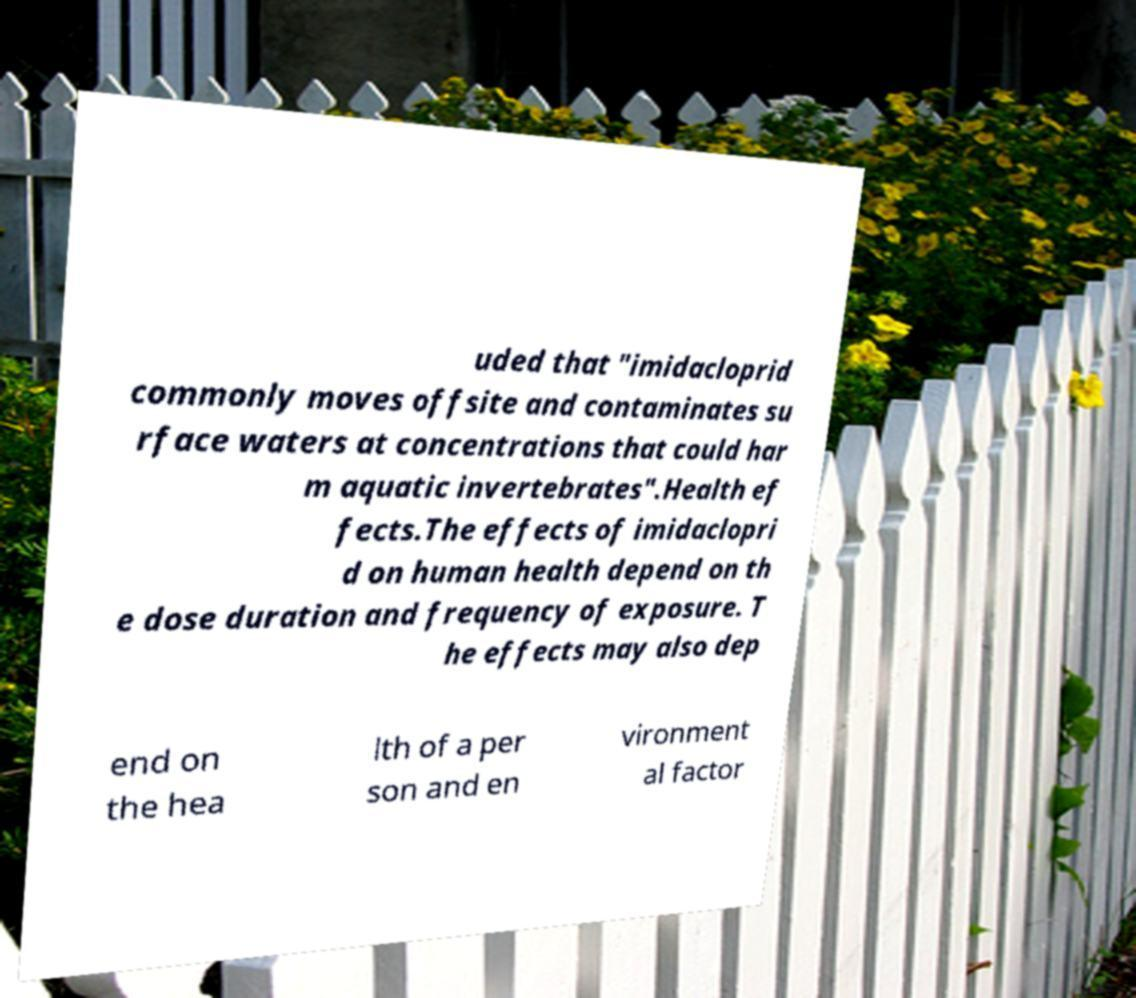For documentation purposes, I need the text within this image transcribed. Could you provide that? uded that "imidacloprid commonly moves offsite and contaminates su rface waters at concentrations that could har m aquatic invertebrates".Health ef fects.The effects of imidaclopri d on human health depend on th e dose duration and frequency of exposure. T he effects may also dep end on the hea lth of a per son and en vironment al factor 